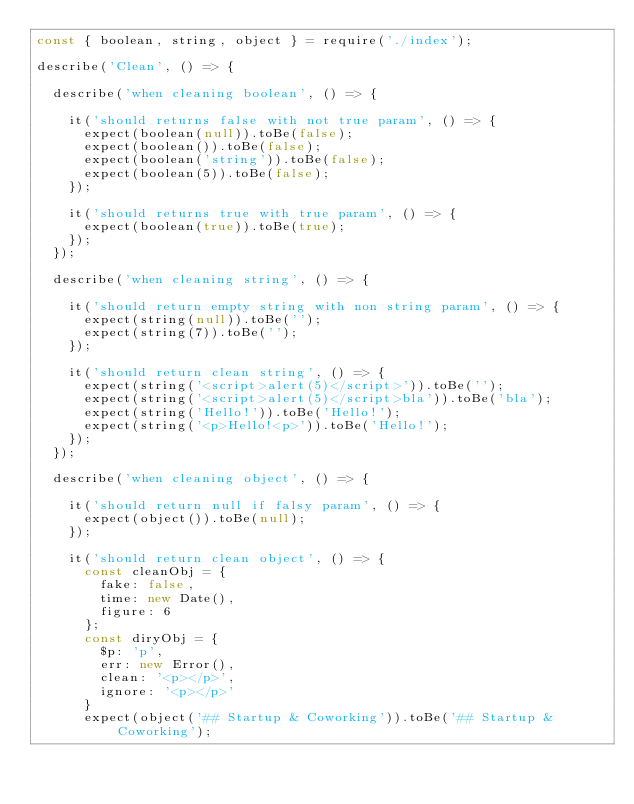Convert code to text. <code><loc_0><loc_0><loc_500><loc_500><_JavaScript_>const { boolean, string, object } = require('./index');

describe('Clean', () => {

  describe('when cleaning boolean', () => {

    it('should returns false with not true param', () => {
      expect(boolean(null)).toBe(false);
      expect(boolean()).toBe(false);
      expect(boolean('string')).toBe(false);
      expect(boolean(5)).toBe(false);
    });

    it('should returns true with true param', () => {
      expect(boolean(true)).toBe(true);
    });
  });

  describe('when cleaning string', () => {

    it('should return empty string with non string param', () => {
      expect(string(null)).toBe('');
      expect(string(7)).toBe('');
    });

    it('should return clean string', () => {
      expect(string('<script>alert(5)</script>')).toBe('');
      expect(string('<script>alert(5)</script>bla')).toBe('bla');
      expect(string('Hello!')).toBe('Hello!');
      expect(string('<p>Hello!<p>')).toBe('Hello!');
    });
  });

  describe('when cleaning object', () => {

    it('should return null if falsy param', () => {
      expect(object()).toBe(null);
    });

    it('should return clean object', () => {
      const cleanObj = {
        fake: false,
        time: new Date(),
        figure: 6
      };
      const diryObj = {
        $p: 'p',
        err: new Error(),
        clean: '<p></p>',
        ignore: '<p></p>'
      }
      expect(object('## Startup & Coworking')).toBe('## Startup & Coworking');</code> 